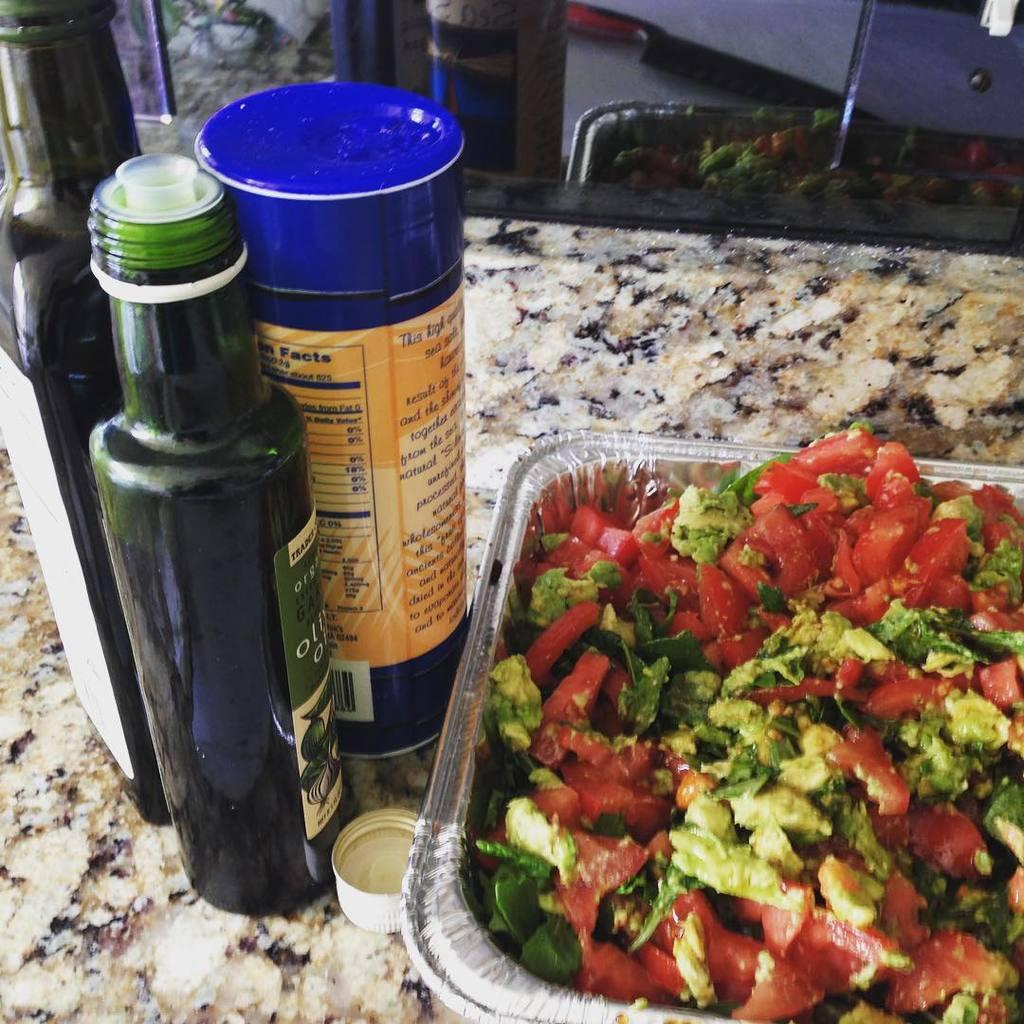What objects can be seen in the image related to liquids or beverages? There are bottles in the image. What object in the image is typically used to seal or close containers? There is a cap in the image. What type of food is visible in the image? There is a container with food in the image. Where is the container with food located? The container with food is placed on a counter top. What architectural feature can be seen in the background of the image? There is a glass door in the background of the image. What type of belief is depicted in the image? There is no depiction of a belief in the image; it features bottles, a cap, a container with food, a counter top, and a glass door. What type of pancake can be seen being destroyed in the image? There is no pancake present in the image, nor is there any destruction taking place. 